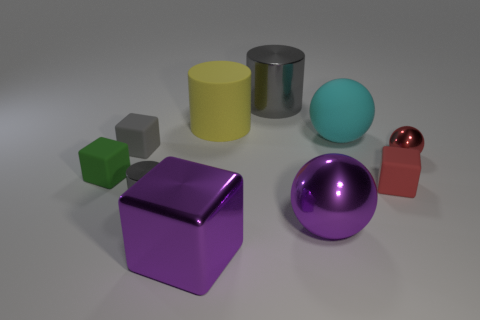How do the textures of the objects in the image compare to each other? The objects in the image showcase a variety of textures. The smooth, shiny spheres and cube have reflective surfaces, indicating a high-gloss finish, like that of polished metal or plastic. In contrast, the matte cylinder has a more subdued appearance, suggesting a texture that absorbs rather than reflects light. 